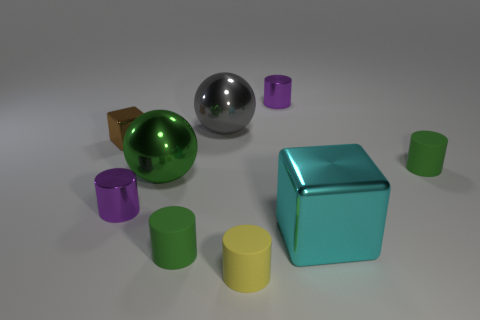Does the tiny purple object in front of the brown block have the same shape as the green rubber thing that is left of the small yellow rubber cylinder?
Keep it short and to the point. Yes. The large metal sphere behind the green rubber object that is to the right of the cyan object is what color?
Keep it short and to the point. Gray. The other small metallic thing that is the same shape as the cyan thing is what color?
Ensure brevity in your answer.  Brown. Is there any other thing that has the same material as the cyan object?
Make the answer very short. Yes. The gray shiny object that is the same shape as the green metal thing is what size?
Ensure brevity in your answer.  Large. What material is the tiny purple object that is to the right of the small yellow rubber cylinder?
Offer a very short reply. Metal. Are there fewer big shiny things that are behind the gray metal ball than tiny matte cylinders?
Offer a very short reply. Yes. There is a small purple object behind the tiny brown shiny object behind the green sphere; what shape is it?
Offer a very short reply. Cylinder. The small shiny cube has what color?
Your response must be concise. Brown. How many other things are there of the same size as the cyan shiny cube?
Offer a very short reply. 2. 